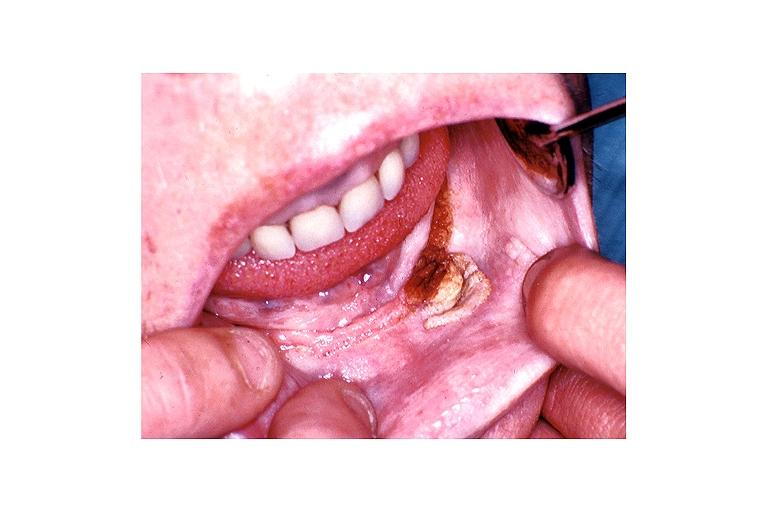does bicornate uterus show verruca vulgaris?
Answer the question using a single word or phrase. No 